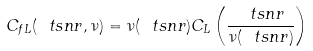Convert formula to latex. <formula><loc_0><loc_0><loc_500><loc_500>C _ { f L } ( \ t s n r , \nu ) = \nu ( \ t s n r ) C _ { L } \left ( \frac { \ t s n r } { \nu ( \ t s n r ) } \right )</formula> 